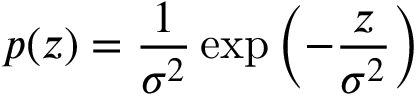Convert formula to latex. <formula><loc_0><loc_0><loc_500><loc_500>p ( z ) = \frac { 1 } { \sigma ^ { 2 } } \exp \left ( - \frac { z } { \sigma ^ { 2 } } \right )</formula> 